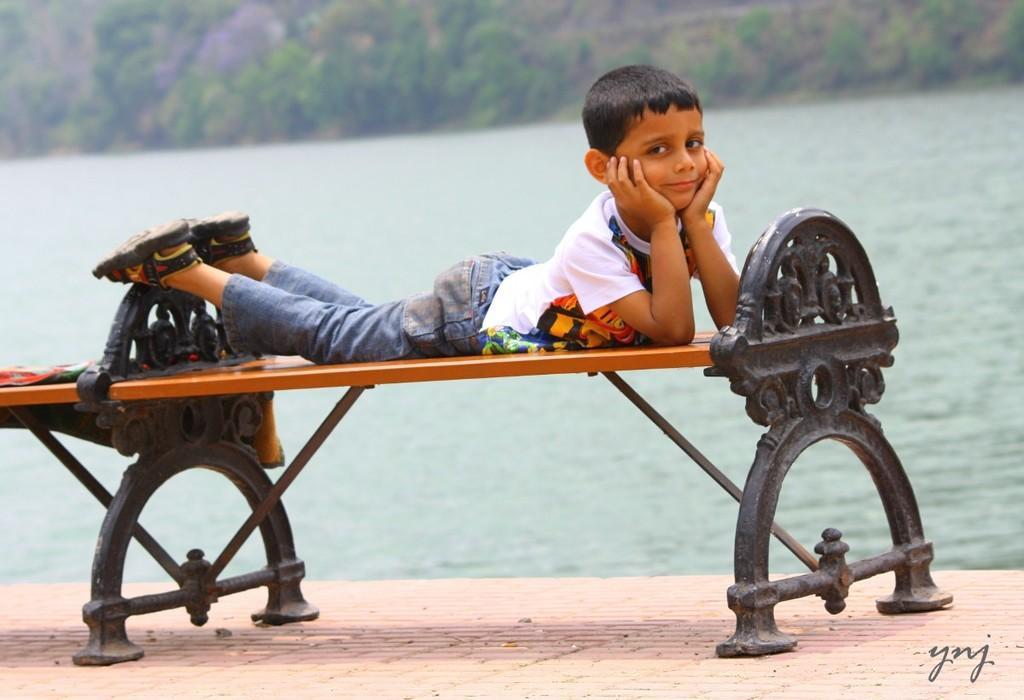In one or two sentences, can you explain what this image depicts? In this image I see a boy who is lying on the bench. In the background I see the water and trees. 